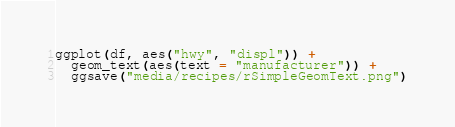<code> <loc_0><loc_0><loc_500><loc_500><_Nim_>ggplot(df, aes("hwy", "displ")) + 
  geom_text(aes(text = "manufacturer")) + 
  ggsave("media/recipes/rSimpleGeomText.png")
</code> 